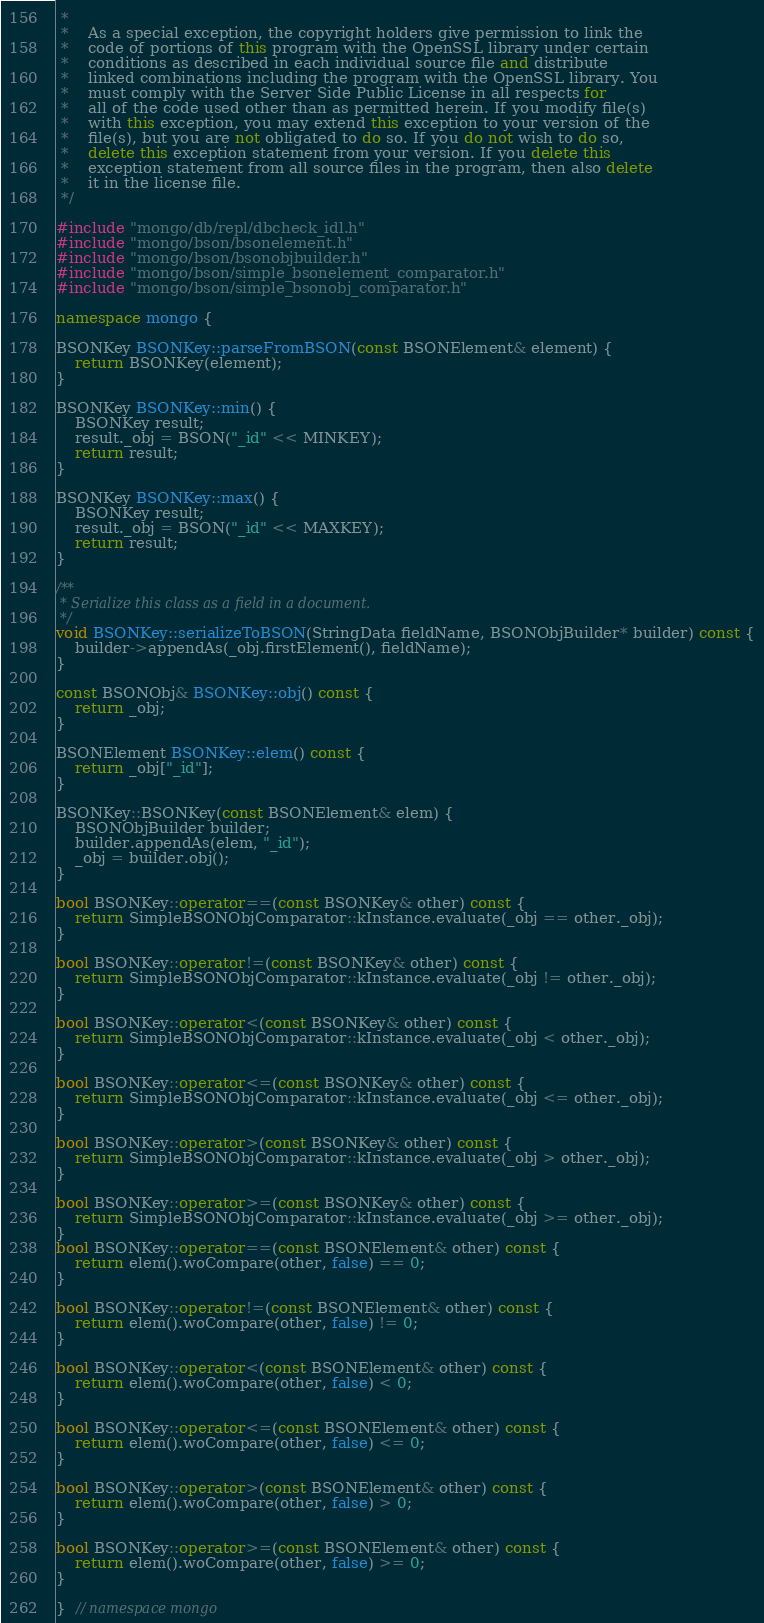Convert code to text. <code><loc_0><loc_0><loc_500><loc_500><_C++_> *
 *    As a special exception, the copyright holders give permission to link the
 *    code of portions of this program with the OpenSSL library under certain
 *    conditions as described in each individual source file and distribute
 *    linked combinations including the program with the OpenSSL library. You
 *    must comply with the Server Side Public License in all respects for
 *    all of the code used other than as permitted herein. If you modify file(s)
 *    with this exception, you may extend this exception to your version of the
 *    file(s), but you are not obligated to do so. If you do not wish to do so,
 *    delete this exception statement from your version. If you delete this
 *    exception statement from all source files in the program, then also delete
 *    it in the license file.
 */

#include "mongo/db/repl/dbcheck_idl.h"
#include "mongo/bson/bsonelement.h"
#include "mongo/bson/bsonobjbuilder.h"
#include "mongo/bson/simple_bsonelement_comparator.h"
#include "mongo/bson/simple_bsonobj_comparator.h"

namespace mongo {

BSONKey BSONKey::parseFromBSON(const BSONElement& element) {
    return BSONKey(element);
}

BSONKey BSONKey::min() {
    BSONKey result;
    result._obj = BSON("_id" << MINKEY);
    return result;
}

BSONKey BSONKey::max() {
    BSONKey result;
    result._obj = BSON("_id" << MAXKEY);
    return result;
}

/**
 * Serialize this class as a field in a document.
 */
void BSONKey::serializeToBSON(StringData fieldName, BSONObjBuilder* builder) const {
    builder->appendAs(_obj.firstElement(), fieldName);
}

const BSONObj& BSONKey::obj() const {
    return _obj;
}

BSONElement BSONKey::elem() const {
    return _obj["_id"];
}

BSONKey::BSONKey(const BSONElement& elem) {
    BSONObjBuilder builder;
    builder.appendAs(elem, "_id");
    _obj = builder.obj();
}

bool BSONKey::operator==(const BSONKey& other) const {
    return SimpleBSONObjComparator::kInstance.evaluate(_obj == other._obj);
}

bool BSONKey::operator!=(const BSONKey& other) const {
    return SimpleBSONObjComparator::kInstance.evaluate(_obj != other._obj);
}

bool BSONKey::operator<(const BSONKey& other) const {
    return SimpleBSONObjComparator::kInstance.evaluate(_obj < other._obj);
}

bool BSONKey::operator<=(const BSONKey& other) const {
    return SimpleBSONObjComparator::kInstance.evaluate(_obj <= other._obj);
}

bool BSONKey::operator>(const BSONKey& other) const {
    return SimpleBSONObjComparator::kInstance.evaluate(_obj > other._obj);
}

bool BSONKey::operator>=(const BSONKey& other) const {
    return SimpleBSONObjComparator::kInstance.evaluate(_obj >= other._obj);
}
bool BSONKey::operator==(const BSONElement& other) const {
    return elem().woCompare(other, false) == 0;
}

bool BSONKey::operator!=(const BSONElement& other) const {
    return elem().woCompare(other, false) != 0;
}

bool BSONKey::operator<(const BSONElement& other) const {
    return elem().woCompare(other, false) < 0;
}

bool BSONKey::operator<=(const BSONElement& other) const {
    return elem().woCompare(other, false) <= 0;
}

bool BSONKey::operator>(const BSONElement& other) const {
    return elem().woCompare(other, false) > 0;
}

bool BSONKey::operator>=(const BSONElement& other) const {
    return elem().woCompare(other, false) >= 0;
}

}  // namespace mongo
</code> 